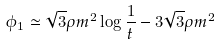Convert formula to latex. <formula><loc_0><loc_0><loc_500><loc_500>\phi _ { 1 } \simeq \sqrt { 3 } \rho m ^ { 2 } \log \frac { 1 } { t } - 3 \sqrt { 3 } \rho m ^ { 2 }</formula> 